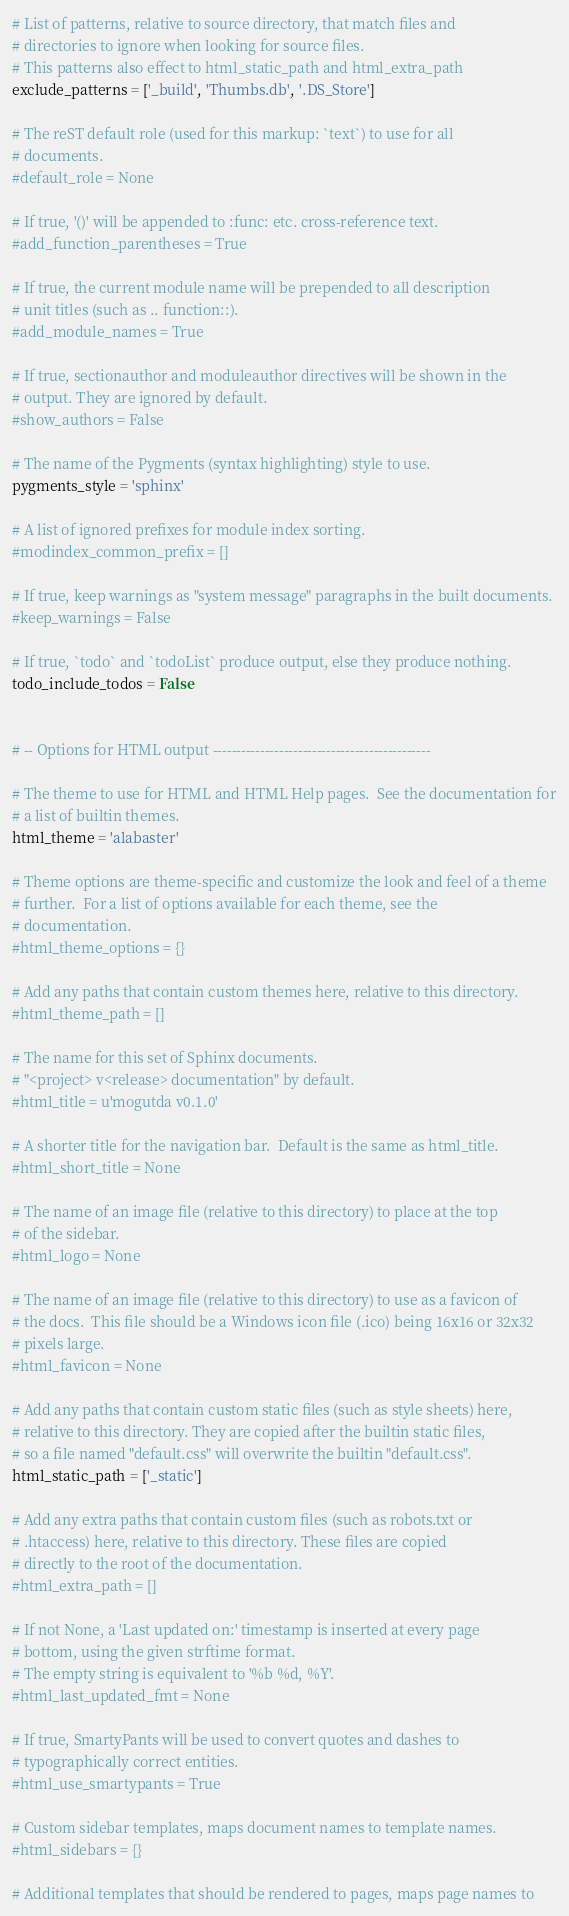Convert code to text. <code><loc_0><loc_0><loc_500><loc_500><_Python_>
# List of patterns, relative to source directory, that match files and
# directories to ignore when looking for source files.
# This patterns also effect to html_static_path and html_extra_path
exclude_patterns = ['_build', 'Thumbs.db', '.DS_Store']

# The reST default role (used for this markup: `text`) to use for all
# documents.
#default_role = None

# If true, '()' will be appended to :func: etc. cross-reference text.
#add_function_parentheses = True

# If true, the current module name will be prepended to all description
# unit titles (such as .. function::).
#add_module_names = True

# If true, sectionauthor and moduleauthor directives will be shown in the
# output. They are ignored by default.
#show_authors = False

# The name of the Pygments (syntax highlighting) style to use.
pygments_style = 'sphinx'

# A list of ignored prefixes for module index sorting.
#modindex_common_prefix = []

# If true, keep warnings as "system message" paragraphs in the built documents.
#keep_warnings = False

# If true, `todo` and `todoList` produce output, else they produce nothing.
todo_include_todos = False


# -- Options for HTML output ----------------------------------------------

# The theme to use for HTML and HTML Help pages.  See the documentation for
# a list of builtin themes.
html_theme = 'alabaster'

# Theme options are theme-specific and customize the look and feel of a theme
# further.  For a list of options available for each theme, see the
# documentation.
#html_theme_options = {}

# Add any paths that contain custom themes here, relative to this directory.
#html_theme_path = []

# The name for this set of Sphinx documents.
# "<project> v<release> documentation" by default.
#html_title = u'mogutda v0.1.0'

# A shorter title for the navigation bar.  Default is the same as html_title.
#html_short_title = None

# The name of an image file (relative to this directory) to place at the top
# of the sidebar.
#html_logo = None

# The name of an image file (relative to this directory) to use as a favicon of
# the docs.  This file should be a Windows icon file (.ico) being 16x16 or 32x32
# pixels large.
#html_favicon = None

# Add any paths that contain custom static files (such as style sheets) here,
# relative to this directory. They are copied after the builtin static files,
# so a file named "default.css" will overwrite the builtin "default.css".
html_static_path = ['_static']

# Add any extra paths that contain custom files (such as robots.txt or
# .htaccess) here, relative to this directory. These files are copied
# directly to the root of the documentation.
#html_extra_path = []

# If not None, a 'Last updated on:' timestamp is inserted at every page
# bottom, using the given strftime format.
# The empty string is equivalent to '%b %d, %Y'.
#html_last_updated_fmt = None

# If true, SmartyPants will be used to convert quotes and dashes to
# typographically correct entities.
#html_use_smartypants = True

# Custom sidebar templates, maps document names to template names.
#html_sidebars = {}

# Additional templates that should be rendered to pages, maps page names to</code> 